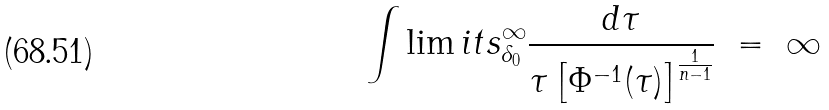Convert formula to latex. <formula><loc_0><loc_0><loc_500><loc_500>\int \lim i t s _ { \delta _ { 0 } } ^ { \infty } \frac { d \tau } { \tau \left [ \Phi ^ { - 1 } ( \tau ) \right ] ^ { \frac { 1 } { n - 1 } } } \ = \ \infty</formula> 